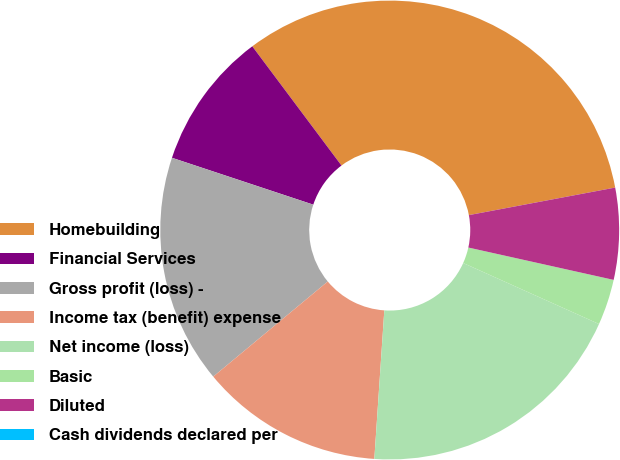Convert chart. <chart><loc_0><loc_0><loc_500><loc_500><pie_chart><fcel>Homebuilding<fcel>Financial Services<fcel>Gross profit (loss) -<fcel>Income tax (benefit) expense<fcel>Net income (loss)<fcel>Basic<fcel>Diluted<fcel>Cash dividends declared per<nl><fcel>32.26%<fcel>9.68%<fcel>16.13%<fcel>12.9%<fcel>19.35%<fcel>3.23%<fcel>6.45%<fcel>0.0%<nl></chart> 